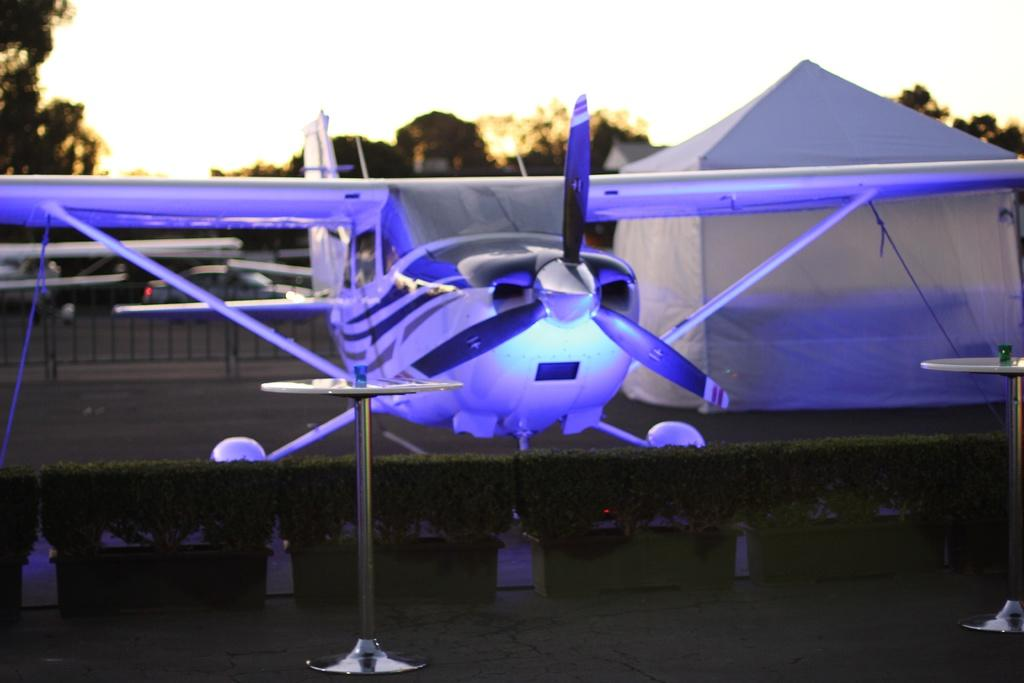What type of vehicle is present in the image? There is an aircraft with lights in the image. What type of vegetation can be seen in the image? There are bushes in the image. What type of furniture is present in the image? There is a table in the image. What type of shelter is visible in the background of the image? There is a tent in the background of the image. What type of natural scenery is visible in the background of the image? There are trees and the sky visible in the background of the image. How many zephyrs are blowing through the tent in the image? There is no mention of zephyrs in the image, and therefore it is impossible to determine their number or presence. 